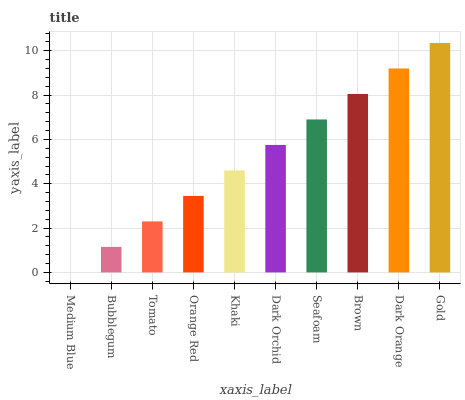Is Medium Blue the minimum?
Answer yes or no. Yes. Is Gold the maximum?
Answer yes or no. Yes. Is Bubblegum the minimum?
Answer yes or no. No. Is Bubblegum the maximum?
Answer yes or no. No. Is Bubblegum greater than Medium Blue?
Answer yes or no. Yes. Is Medium Blue less than Bubblegum?
Answer yes or no. Yes. Is Medium Blue greater than Bubblegum?
Answer yes or no. No. Is Bubblegum less than Medium Blue?
Answer yes or no. No. Is Dark Orchid the high median?
Answer yes or no. Yes. Is Khaki the low median?
Answer yes or no. Yes. Is Medium Blue the high median?
Answer yes or no. No. Is Orange Red the low median?
Answer yes or no. No. 